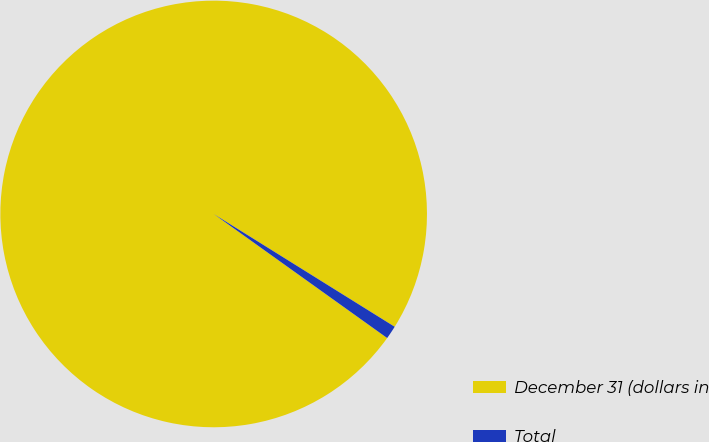Convert chart. <chart><loc_0><loc_0><loc_500><loc_500><pie_chart><fcel>December 31 (dollars in<fcel>Total<nl><fcel>98.99%<fcel>1.01%<nl></chart> 